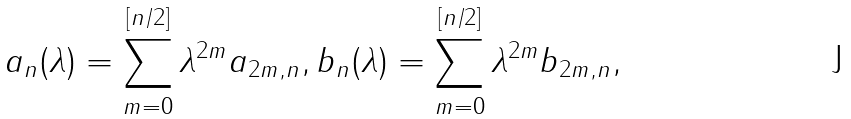Convert formula to latex. <formula><loc_0><loc_0><loc_500><loc_500>a _ { n } ( \lambda ) = \sum _ { m = 0 } ^ { [ n / 2 ] } \lambda ^ { 2 m } a _ { 2 m , n } , b _ { n } ( \lambda ) = \sum _ { m = 0 } ^ { [ n / 2 ] } \lambda ^ { 2 m } b _ { 2 m , n } ,</formula> 